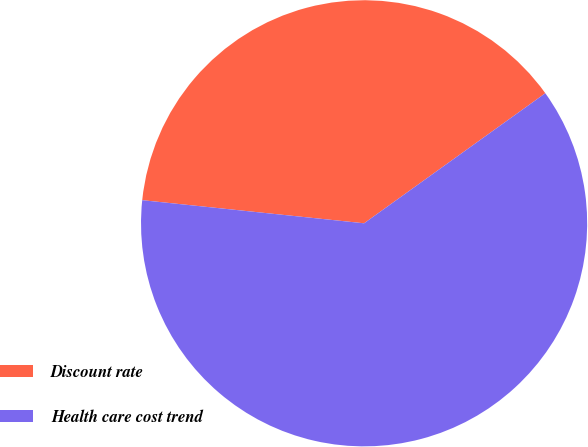<chart> <loc_0><loc_0><loc_500><loc_500><pie_chart><fcel>Discount rate<fcel>Health care cost trend<nl><fcel>38.44%<fcel>61.56%<nl></chart> 